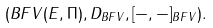<formula> <loc_0><loc_0><loc_500><loc_500>( B F V ( E , \Pi ) , D _ { B F V } , [ - , - ] _ { B F V } ) .</formula> 